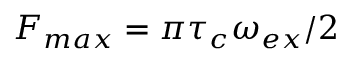<formula> <loc_0><loc_0><loc_500><loc_500>F _ { \max } = \pi \tau _ { c } \omega _ { e x } / 2</formula> 